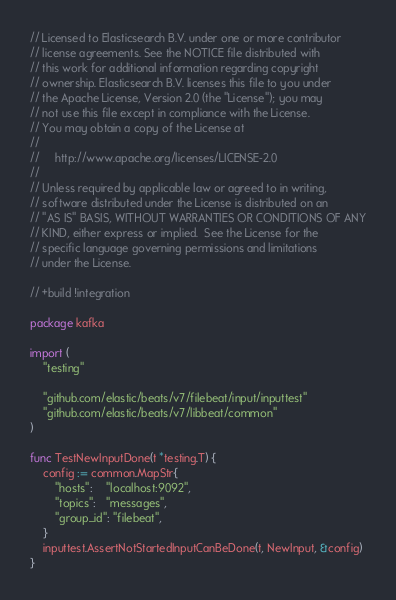<code> <loc_0><loc_0><loc_500><loc_500><_Go_>// Licensed to Elasticsearch B.V. under one or more contributor
// license agreements. See the NOTICE file distributed with
// this work for additional information regarding copyright
// ownership. Elasticsearch B.V. licenses this file to you under
// the Apache License, Version 2.0 (the "License"); you may
// not use this file except in compliance with the License.
// You may obtain a copy of the License at
//
//     http://www.apache.org/licenses/LICENSE-2.0
//
// Unless required by applicable law or agreed to in writing,
// software distributed under the License is distributed on an
// "AS IS" BASIS, WITHOUT WARRANTIES OR CONDITIONS OF ANY
// KIND, either express or implied.  See the License for the
// specific language governing permissions and limitations
// under the License.

// +build !integration

package kafka

import (
	"testing"

	"github.com/elastic/beats/v7/filebeat/input/inputtest"
	"github.com/elastic/beats/v7/libbeat/common"
)

func TestNewInputDone(t *testing.T) {
	config := common.MapStr{
		"hosts":    "localhost:9092",
		"topics":   "messages",
		"group_id": "filebeat",
	}
	inputtest.AssertNotStartedInputCanBeDone(t, NewInput, &config)
}
</code> 